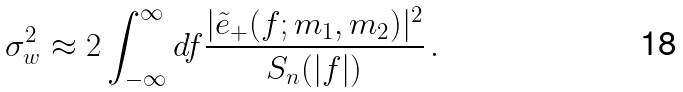Convert formula to latex. <formula><loc_0><loc_0><loc_500><loc_500>\sigma ^ { 2 } _ { w } \approx 2 \int _ { - \infty } ^ { \infty } d f \frac { | \tilde { e } _ { + } ( f ; m _ { 1 } , m _ { 2 } ) | ^ { 2 } } { S _ { n } ( | f | ) } \, .</formula> 